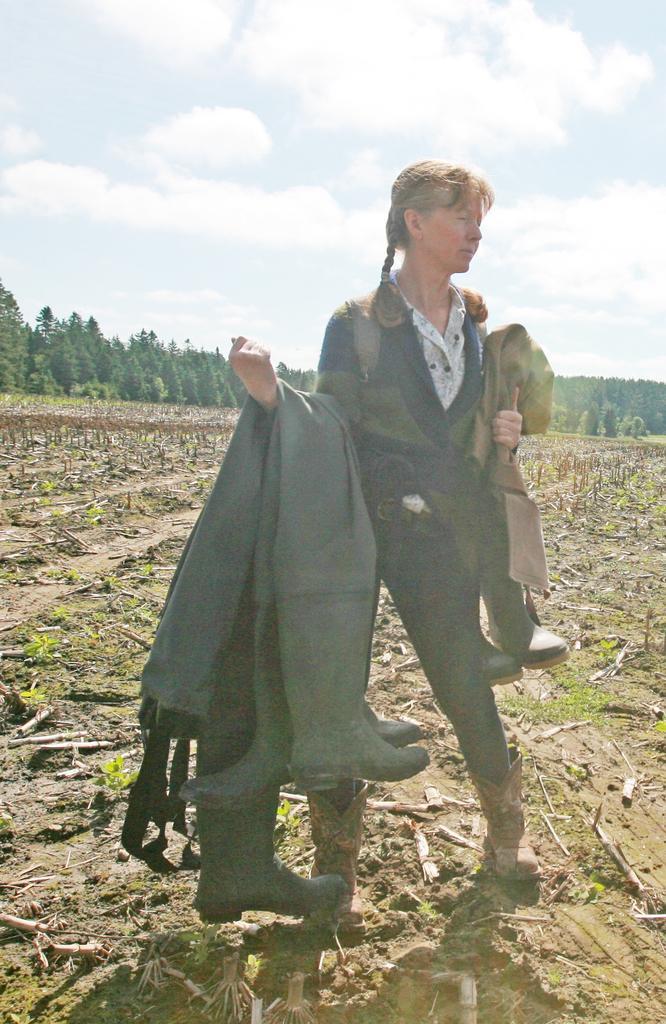In one or two sentences, can you explain what this image depicts? In this picture we can see a woman holding boots with her hands and standing on the ground and in the background we can see plants, sticks, trees and the sky with clouds. 